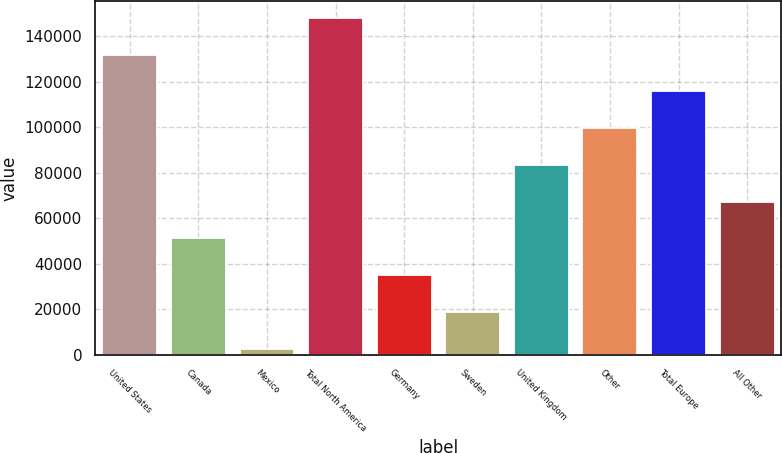<chart> <loc_0><loc_0><loc_500><loc_500><bar_chart><fcel>United States<fcel>Canada<fcel>Mexico<fcel>Total North America<fcel>Germany<fcel>Sweden<fcel>United Kingdom<fcel>Other<fcel>Total Europe<fcel>All Other<nl><fcel>132006<fcel>51194.2<fcel>2707<fcel>148169<fcel>35031.8<fcel>18869.4<fcel>83519<fcel>99681.4<fcel>115844<fcel>67356.6<nl></chart> 